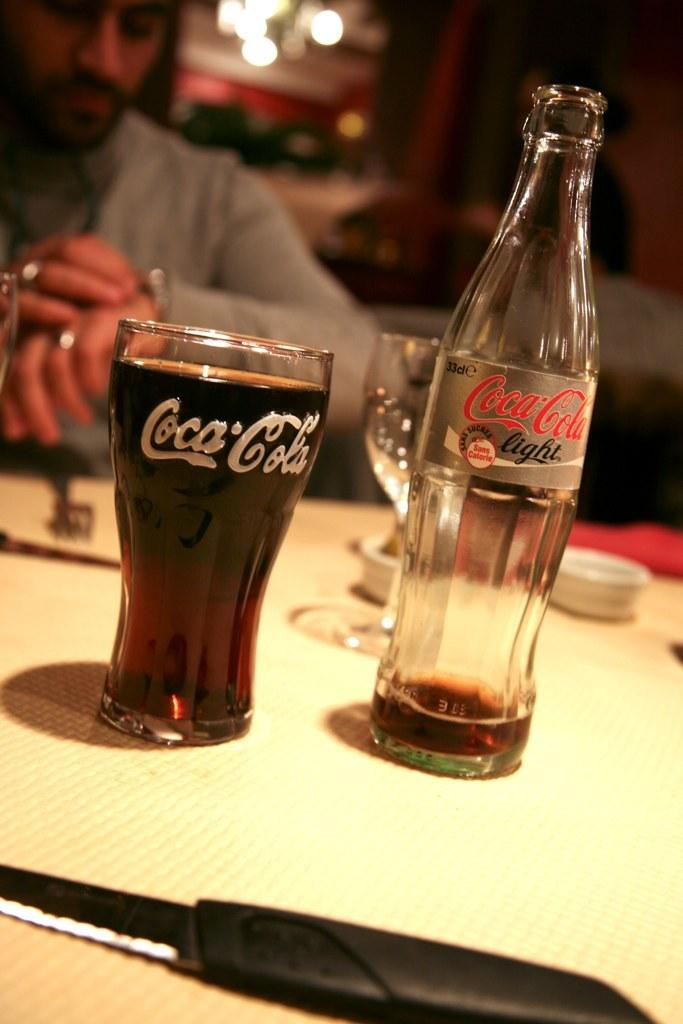<image>
Describe the image concisely. Glass of coca cola in front of a man and a empty coca cola bottle 